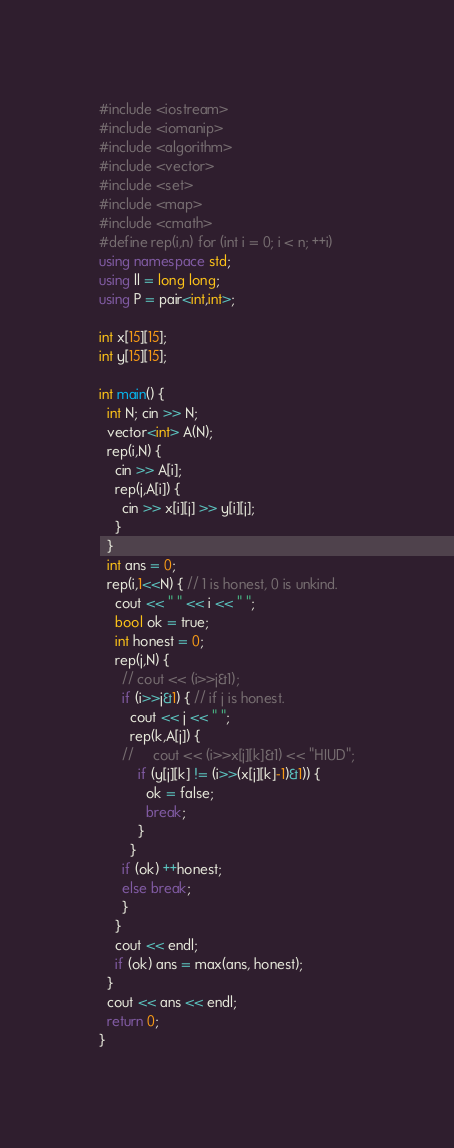Convert code to text. <code><loc_0><loc_0><loc_500><loc_500><_C++_>#include <iostream>
#include <iomanip>
#include <algorithm>
#include <vector>
#include <set>
#include <map>
#include <cmath>
#define rep(i,n) for (int i = 0; i < n; ++i)
using namespace std;
using ll = long long;
using P = pair<int,int>;

int x[15][15];
int y[15][15];

int main() {
  int N; cin >> N;
  vector<int> A(N);
  rep(i,N) {
    cin >> A[i];
    rep(j,A[i]) {
      cin >> x[i][j] >> y[i][j];
    }
  }
  int ans = 0;
  rep(i,1<<N) { // 1 is honest, 0 is unkind.
    cout << " " << i << " ";
    bool ok = true;
    int honest = 0;
    rep(j,N) {
      // cout << (i>>j&1);
      if (i>>j&1) { // if j is honest.
        cout << j << " ";
        rep(k,A[j]) {
      //     cout << (i>>x[j][k]&1) << "HIUD";
          if (y[j][k] != (i>>(x[j][k]-1)&1)) {
            ok = false;
            break;
          }
        }
      if (ok) ++honest;
      else break;
      }
    }
    cout << endl;
    if (ok) ans = max(ans, honest);
  }
  cout << ans << endl;
  return 0;
}</code> 